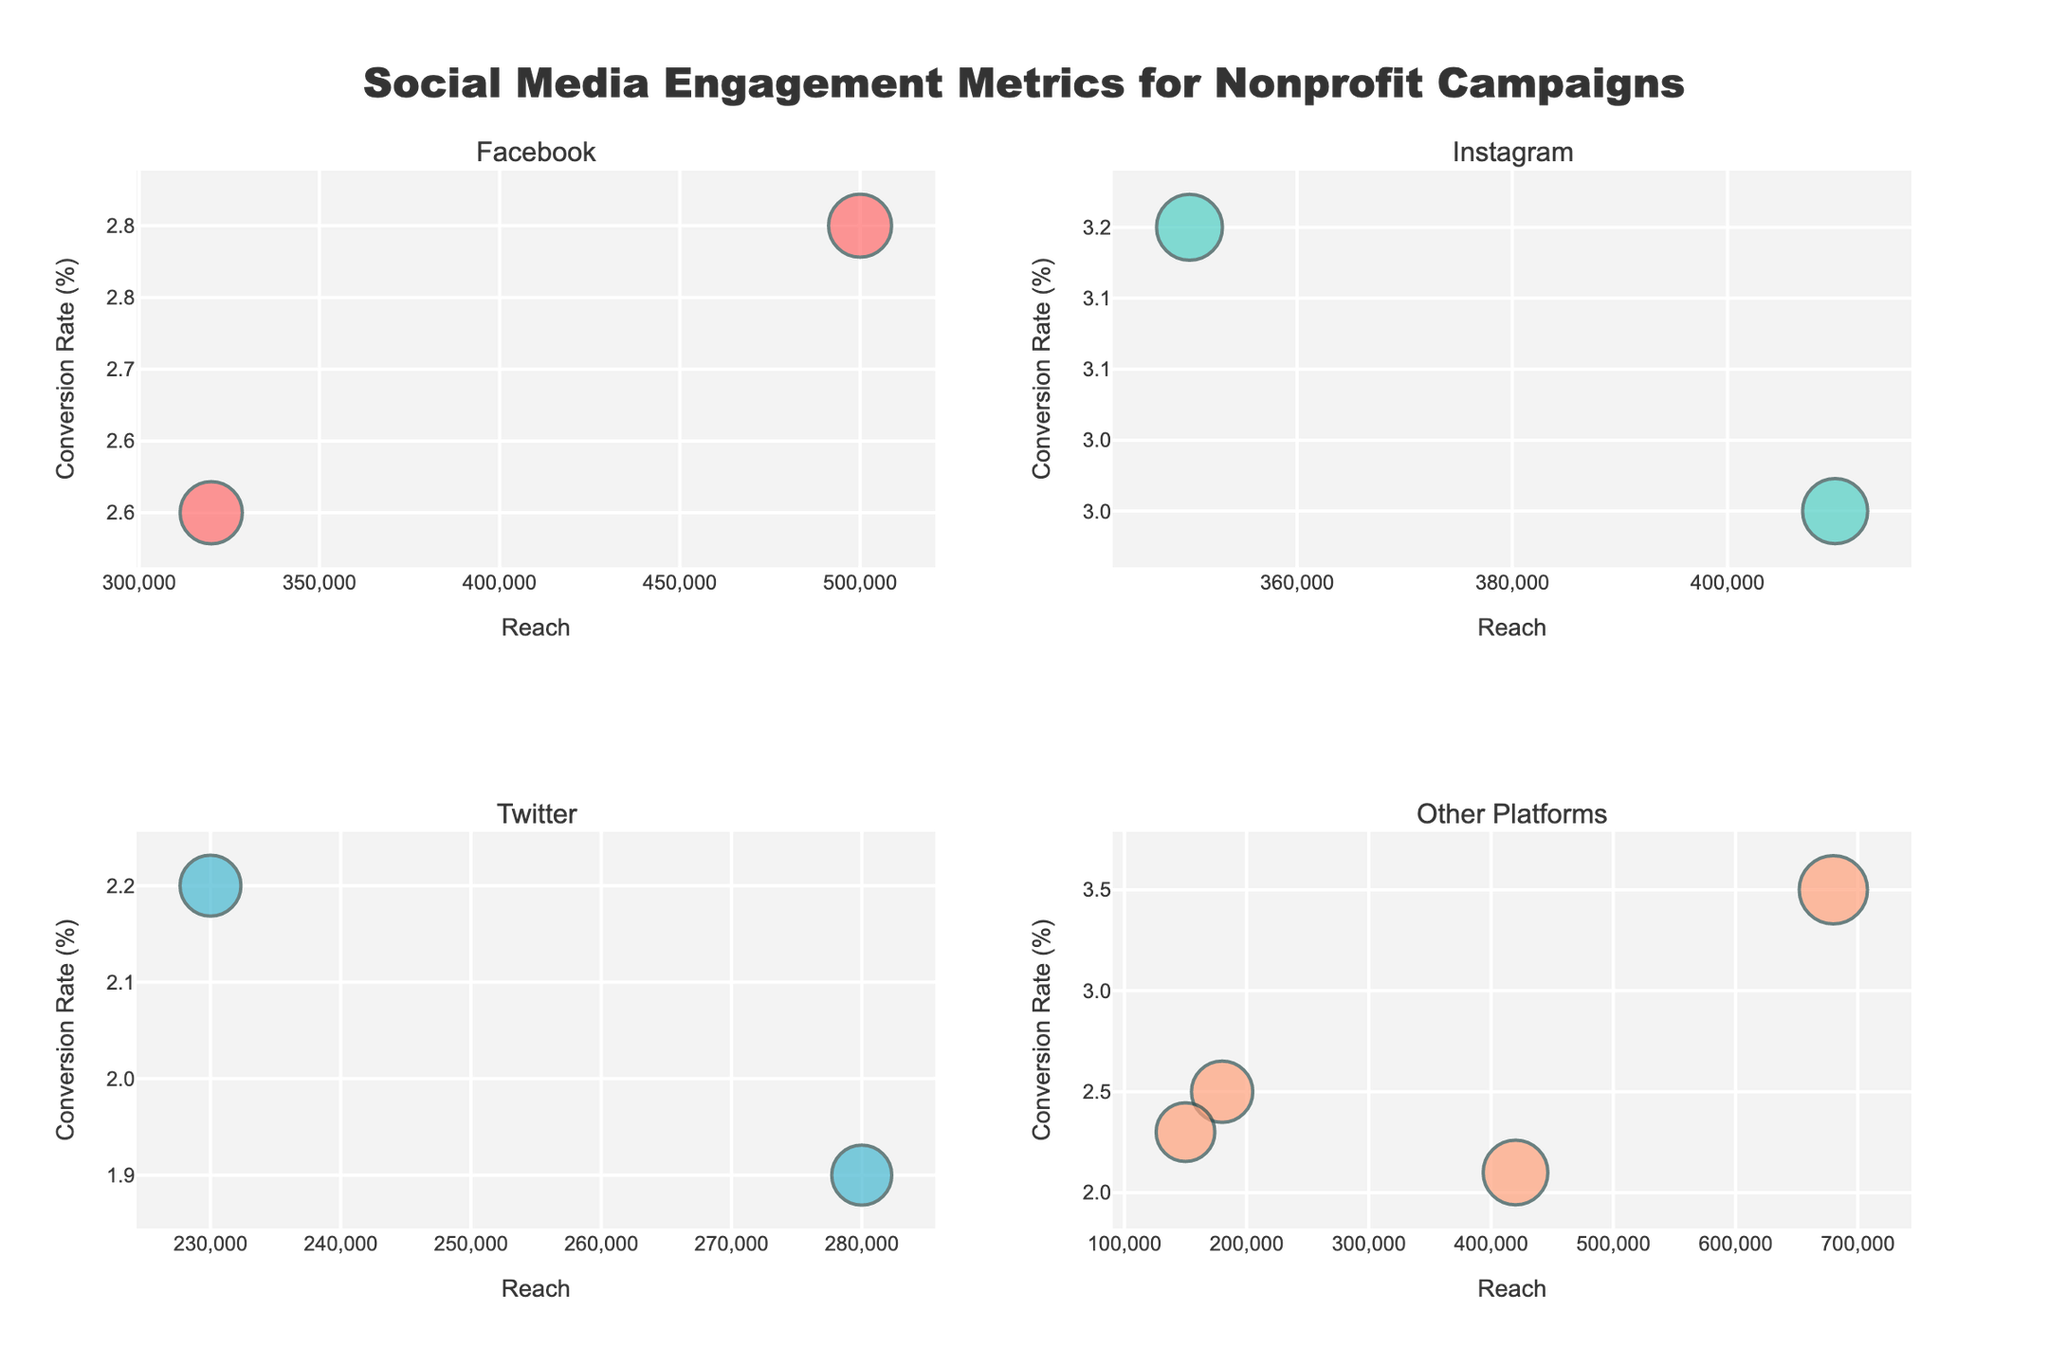Which campaign has the highest reach on Facebook? The subplots are divided by platform, so for Facebook, check the subplot titled "Facebook" and identify the campaign with the highest reach.
Answer: Clean Water Initiative What is the conversion rate of the Women Empowerment Fund on TikTok? Look at the subplot titled "Other Platforms," find the Women Empowerment Fund bubble, and read its conversion rate.
Answer: 3.5% Which platform's campaigns have the highest average engagement score? Calculate the average engagement score for each platform and compare. For Facebook: (75+73)/2, Instagram: (82+80)/2, Twitter: (68+70)/2, Other Platforms: (71+79+88+65)/4.
Answer: Instagram How does the engagement score of Clean Water Initiative compare to Hunger Relief Program? Compare the sizes of the bubbles for each in their respective subplots. Clean Water Initiative (75) and Hunger Relief Program (82).
Answer: Hunger Relief Program has a higher engagement score Which platform has the highest conversion rate in the figure? Identify the platform with the bubble that has the largest y-axis value (Conversion Rate).
Answer: TikTok (Women Empowerment Fund at 3.5%) What is the difference in reach between the Refugee Support Network and Climate Action Now? Subtract the reach of Climate Action Now (180,000) from the reach of Refugee Support Network (320,000).
Answer: 140,000 Which campaign on Twitter has the lowest conversion rate? In the subplots, find the Twitter subplot and identify the campaign with the lowest y-axis value.
Answer: Education for All What's the size of the bubble representing Animal Welfare Project on YouTube? The size represents the engagement score shown by the relative size of the bubble in the subplot titled "Other Platforms."
Answer: 79 How do the reach values of the top two campaigns on Instagram compare? Identify the campaigns on the Instagram subplot, and compare their reach values. Hunger Relief Program (350,000) and Youth Leadership Academy (410,000).
Answer: Youth Leadership Academy has a higher reach Comparing all platforms, which campaign has the lowest engagement score? Look at all subplots to find the smallest bubble, which indicates the lowest engagement score.
Answer: Mental Health Awareness on Pinterest 